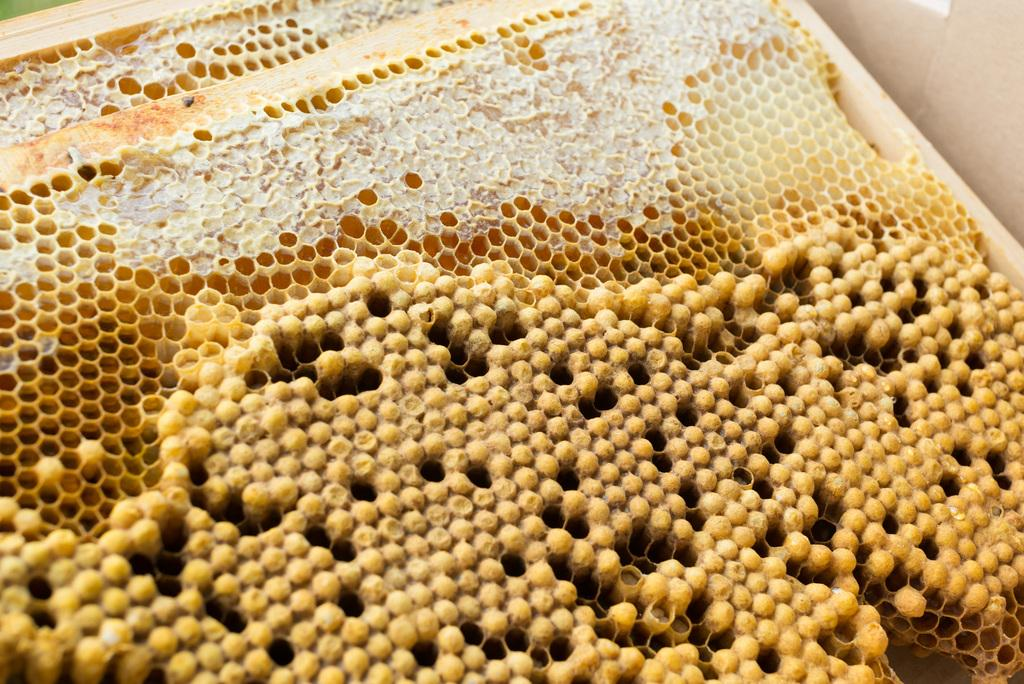What is the main subject of the image? The main subject of the image is a honeycomb. Can you describe the honeycomb in the image? The honeycomb appears to be a structure made by bees to store honey and pollen. What is the income of the honeycomb in the image? There is no income associated with the honeycomb in the image, as it is a natural structure made by bees. Can you tell me how fast the honeycomb is running in the image? The honeycomb is not an object that can run, as it is a stationary structure made by bees. 